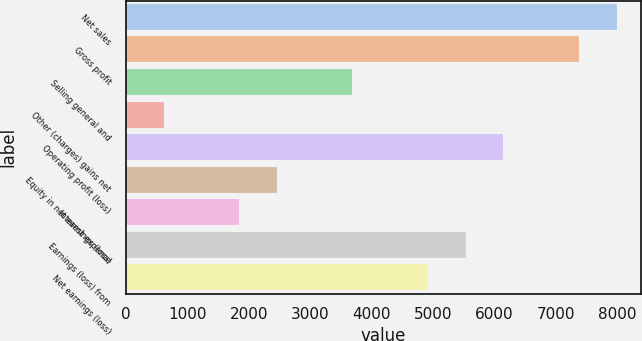Convert chart. <chart><loc_0><loc_0><loc_500><loc_500><bar_chart><fcel>Net sales<fcel>Gross profit<fcel>Selling general and<fcel>Other (charges) gains net<fcel>Operating profit (loss)<fcel>Equity in net earnings (loss)<fcel>Interest expense<fcel>Earnings (loss) from<fcel>Net earnings (loss)<nl><fcel>7980.8<fcel>7367.2<fcel>3685.6<fcel>617.6<fcel>6140<fcel>2458.4<fcel>1844.8<fcel>5526.4<fcel>4912.8<nl></chart> 